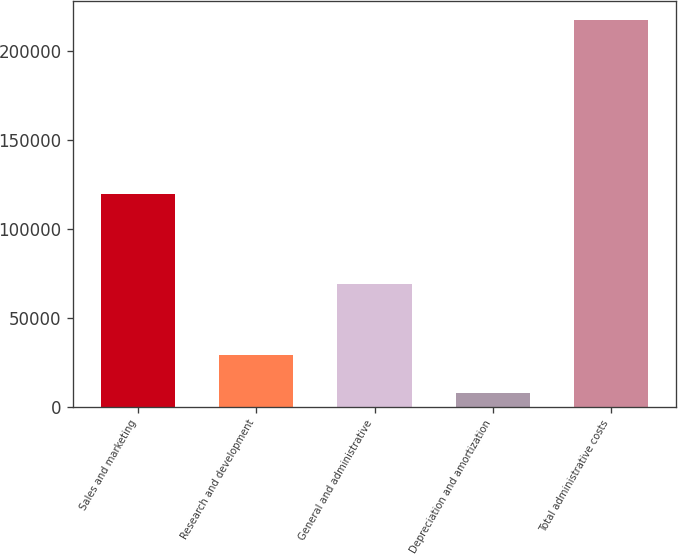Convert chart to OTSL. <chart><loc_0><loc_0><loc_500><loc_500><bar_chart><fcel>Sales and marketing<fcel>Research and development<fcel>General and administrative<fcel>Depreciation and amortization<fcel>Total administrative costs<nl><fcel>119258<fcel>28761<fcel>69046<fcel>7834<fcel>217104<nl></chart> 